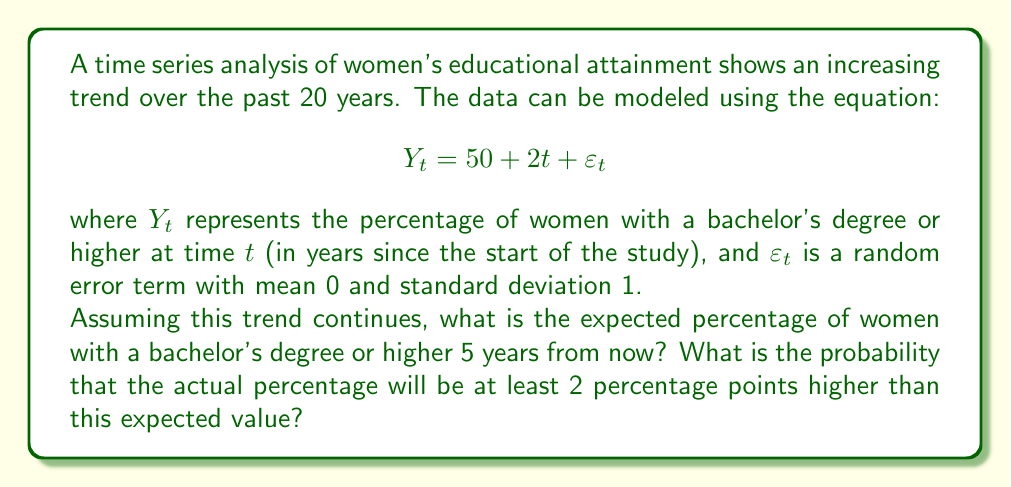Can you solve this math problem? To solve this problem, we'll follow these steps:

1. Calculate the expected value for $Y_t$ at $t = 25$ (5 years from now, given 20 years of data):

   $$E[Y_{25}] = 50 + 2(25) = 50 + 50 = 100$$

2. The expected percentage 5 years from now is 100%.

3. To find the probability that the actual percentage will be at least 2 percentage points higher, we need to consider the random error term $\varepsilon_t$.

4. The question is equivalent to finding $P(Y_{25} \geq 102)$ or $P(\varepsilon_{25} \geq 2)$, since:

   $$Y_{25} = 100 + \varepsilon_{25}$$

5. We know that $\varepsilon_t$ follows a normal distribution with mean 0 and standard deviation 1. To find the probability, we need to calculate the z-score:

   $$z = \frac{2 - 0}{1} = 2$$

6. The probability we're looking for is the area to the right of z = 2 on the standard normal distribution. We can use a z-table or a statistical calculator to find this probability:

   $$P(\varepsilon_{25} \geq 2) = 1 - \Phi(2) \approx 0.0228$$

   where $\Phi(z)$ is the cumulative distribution function of the standard normal distribution.

7. Therefore, the probability that the actual percentage will be at least 2 percentage points higher than the expected value is approximately 0.0228 or 2.28%.
Answer: Expected percentage: 100%. Probability of being at least 2 percentage points higher: 0.0228. 